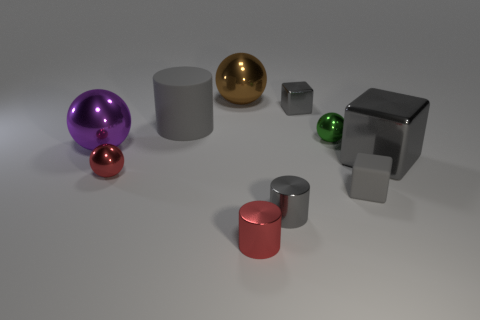Does the tiny shiny block have the same color as the big cylinder?
Provide a succinct answer. Yes. There is a block behind the large purple shiny object; what is its color?
Your answer should be compact. Gray. Is there a tiny yellow thing that has the same shape as the brown metal thing?
Your response must be concise. No. How many red objects are small metal cylinders or large spheres?
Keep it short and to the point. 1. Are there any things of the same size as the red sphere?
Give a very brief answer. Yes. What number of large gray objects are there?
Keep it short and to the point. 2. How many large things are either red shiny spheres or gray cylinders?
Your answer should be compact. 1. The big shiny sphere that is behind the tiny shiny ball behind the gray shiny block that is right of the tiny shiny cube is what color?
Your answer should be very brief. Brown. How many other objects are there of the same color as the tiny metal block?
Your answer should be very brief. 4. What number of shiny objects are small gray things or big yellow cylinders?
Provide a short and direct response. 2. 